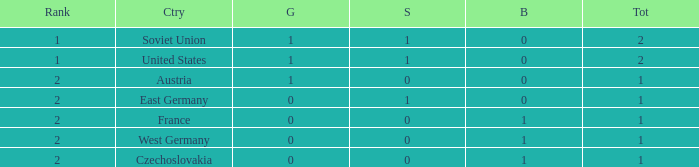What is the standing of a team with 0 gold and fewer than 0 silver medals? None. 